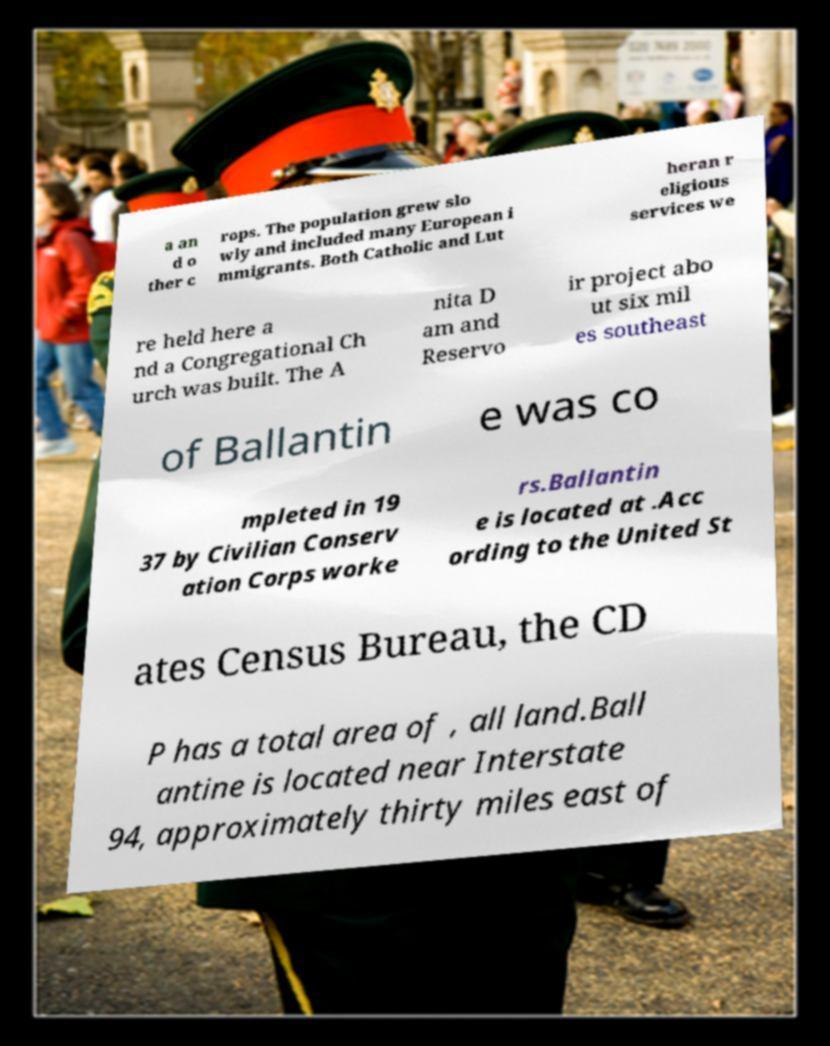Could you extract and type out the text from this image? a an d o ther c rops. The population grew slo wly and included many European i mmigrants. Both Catholic and Lut heran r eligious services we re held here a nd a Congregational Ch urch was built. The A nita D am and Reservo ir project abo ut six mil es southeast of Ballantin e was co mpleted in 19 37 by Civilian Conserv ation Corps worke rs.Ballantin e is located at .Acc ording to the United St ates Census Bureau, the CD P has a total area of , all land.Ball antine is located near Interstate 94, approximately thirty miles east of 